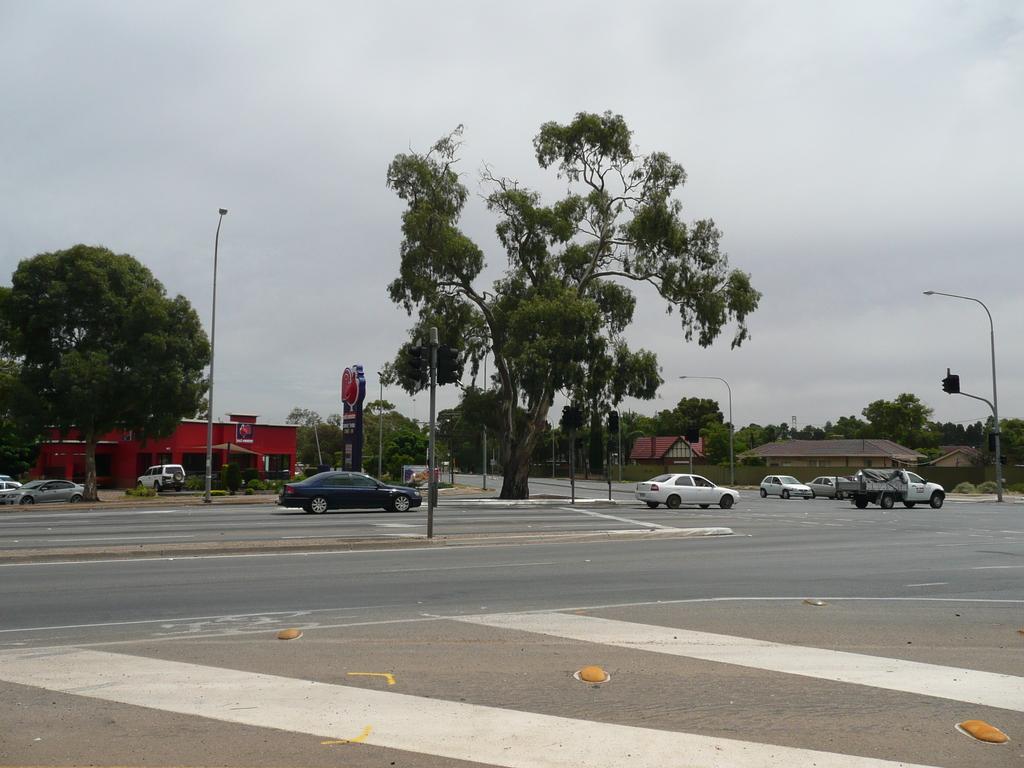Can you describe this image briefly? In this picture I can see there is a road and there are few vehicles moving on the road and there are few street lights and there are traffic lights attached to the poles and there is a red color building on to left and there are few vehicles parked here and there are few trees, on to right there is a junction and there are few buildings. There are few markings on the road and the sky is clear. 